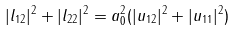Convert formula to latex. <formula><loc_0><loc_0><loc_500><loc_500>| l _ { 1 2 } | ^ { 2 } + | l _ { 2 2 } | ^ { 2 } = a _ { 0 } ^ { 2 } ( | u _ { 1 2 } | ^ { 2 } + | u _ { 1 1 } | ^ { 2 } )</formula> 